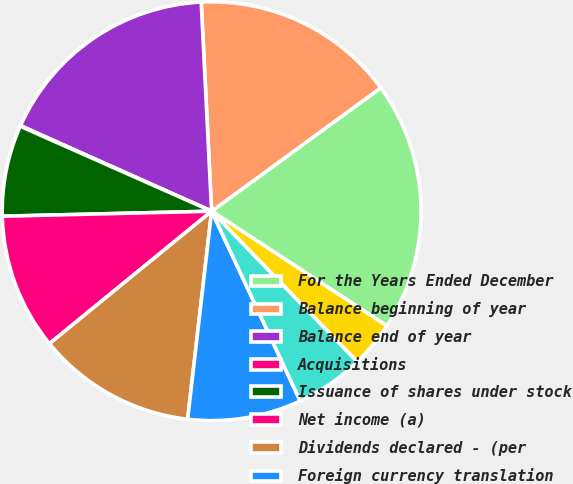<chart> <loc_0><loc_0><loc_500><loc_500><pie_chart><fcel>For the Years Ended December<fcel>Balance beginning of year<fcel>Balance end of year<fcel>Acquisitions<fcel>Issuance of shares under stock<fcel>Net income (a)<fcel>Dividends declared - (per<fcel>Foreign currency translation<fcel>Unrealized investment holding<fcel>Minimum pension liability<nl><fcel>19.25%<fcel>15.76%<fcel>17.51%<fcel>0.05%<fcel>7.03%<fcel>10.52%<fcel>12.27%<fcel>8.78%<fcel>5.29%<fcel>3.54%<nl></chart> 